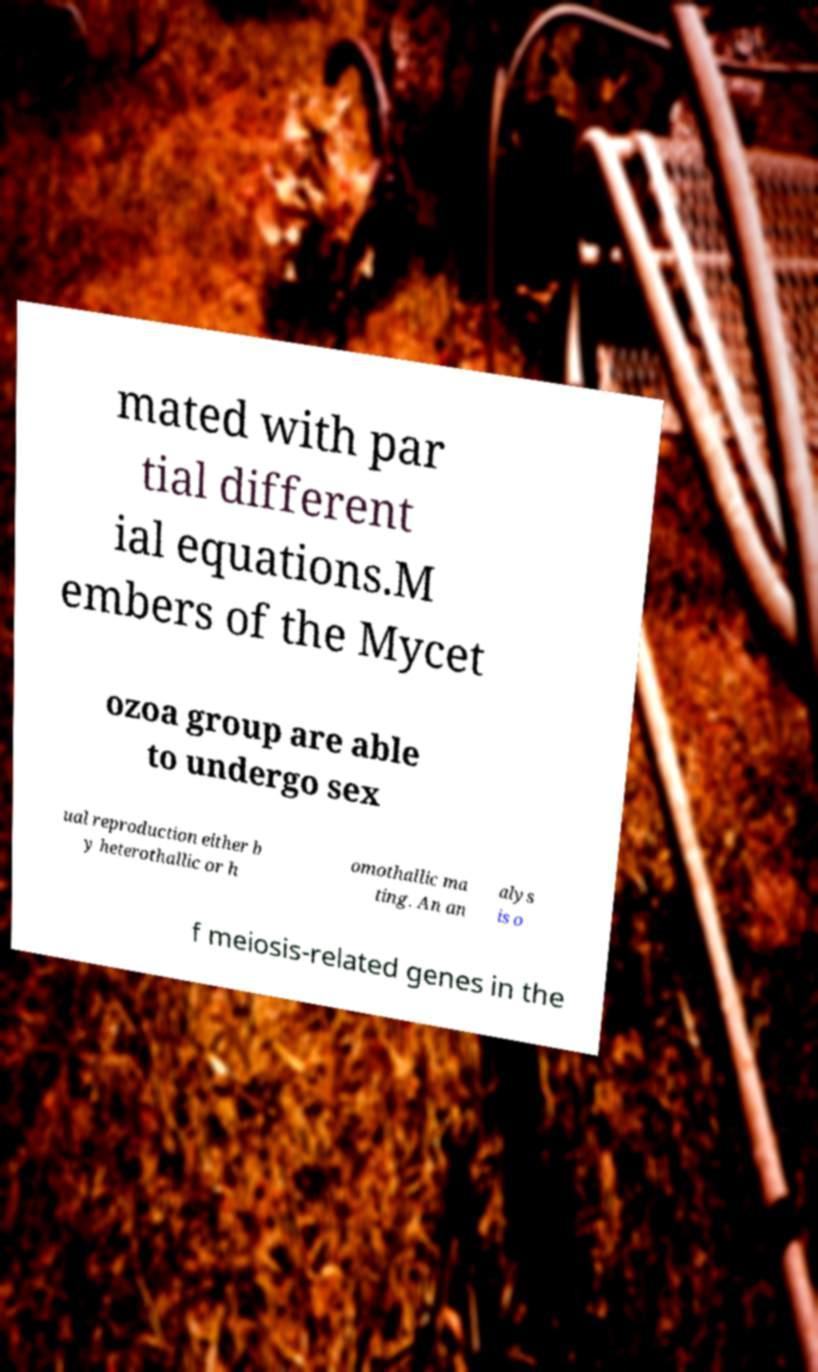Can you read and provide the text displayed in the image?This photo seems to have some interesting text. Can you extract and type it out for me? mated with par tial different ial equations.M embers of the Mycet ozoa group are able to undergo sex ual reproduction either b y heterothallic or h omothallic ma ting. An an alys is o f meiosis-related genes in the 